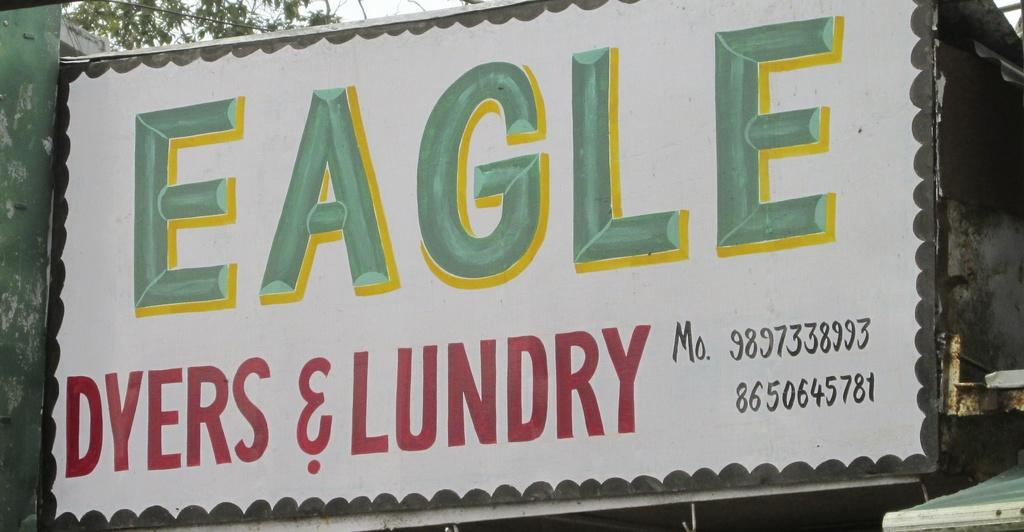What is the main object in the image? There is a hoarding in the image. What is written on the hoarding? The hoarding has the word "eagle" written on it. What can be seen behind the hoarding? There is a tree behind the hoarding. Can you describe any other elements in the image? There is a wire visible in the image. What month is it in the image? The month is not mentioned or visible in the image, so it cannot be determined. 